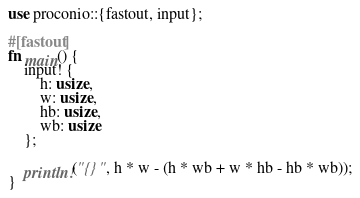<code> <loc_0><loc_0><loc_500><loc_500><_Rust_>use proconio::{fastout, input};

#[fastout]
fn main() {
    input! {
        h: usize,
        w: usize,
        hb: usize,
        wb: usize
    };

    println!("{}", h * w - (h * wb + w * hb - hb * wb));
}
</code> 